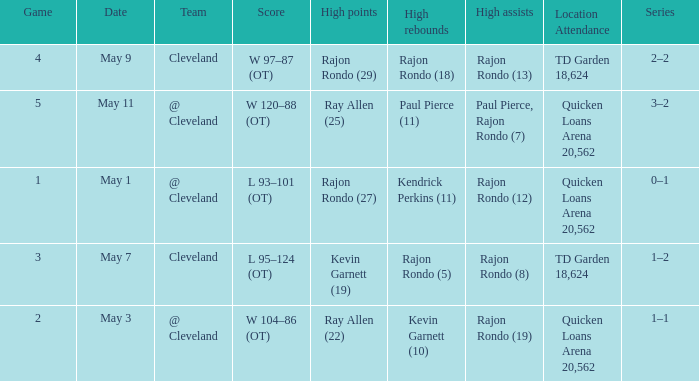Where does the team play May 3? @ Cleveland. 